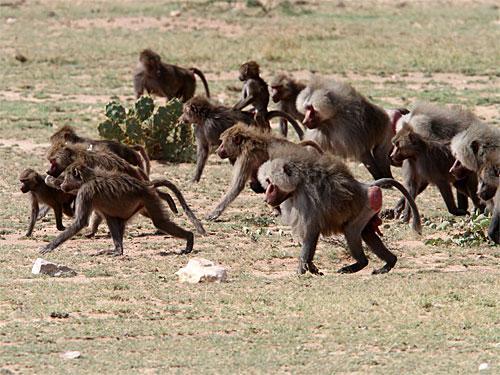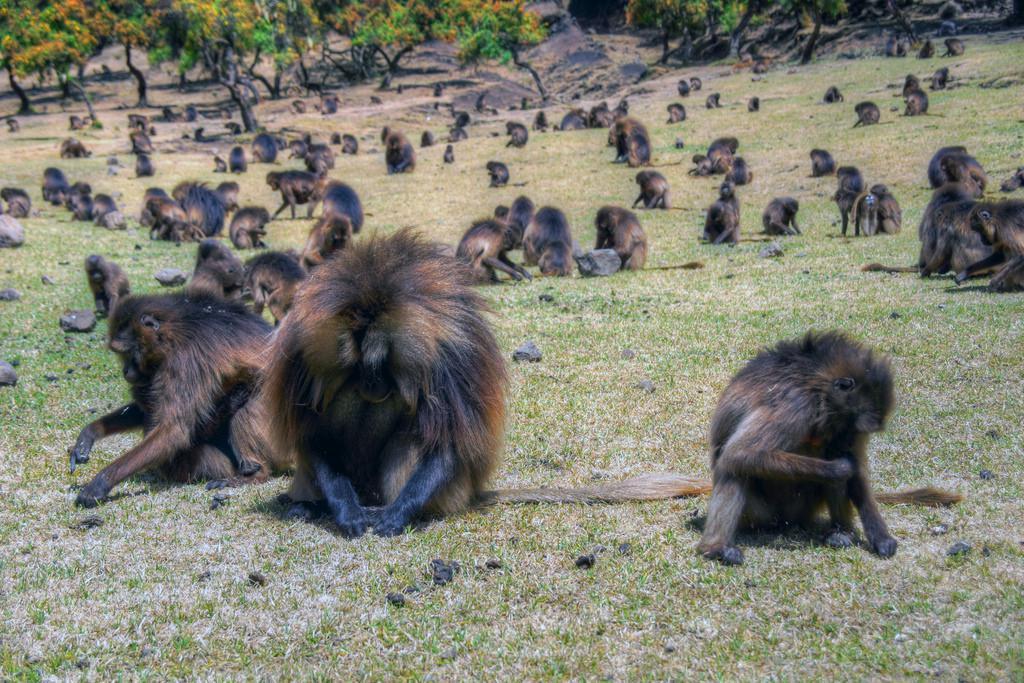The first image is the image on the left, the second image is the image on the right. For the images shown, is this caption "The right image contains fewer than a third of the number of baboons on the left." true? Answer yes or no. No. 